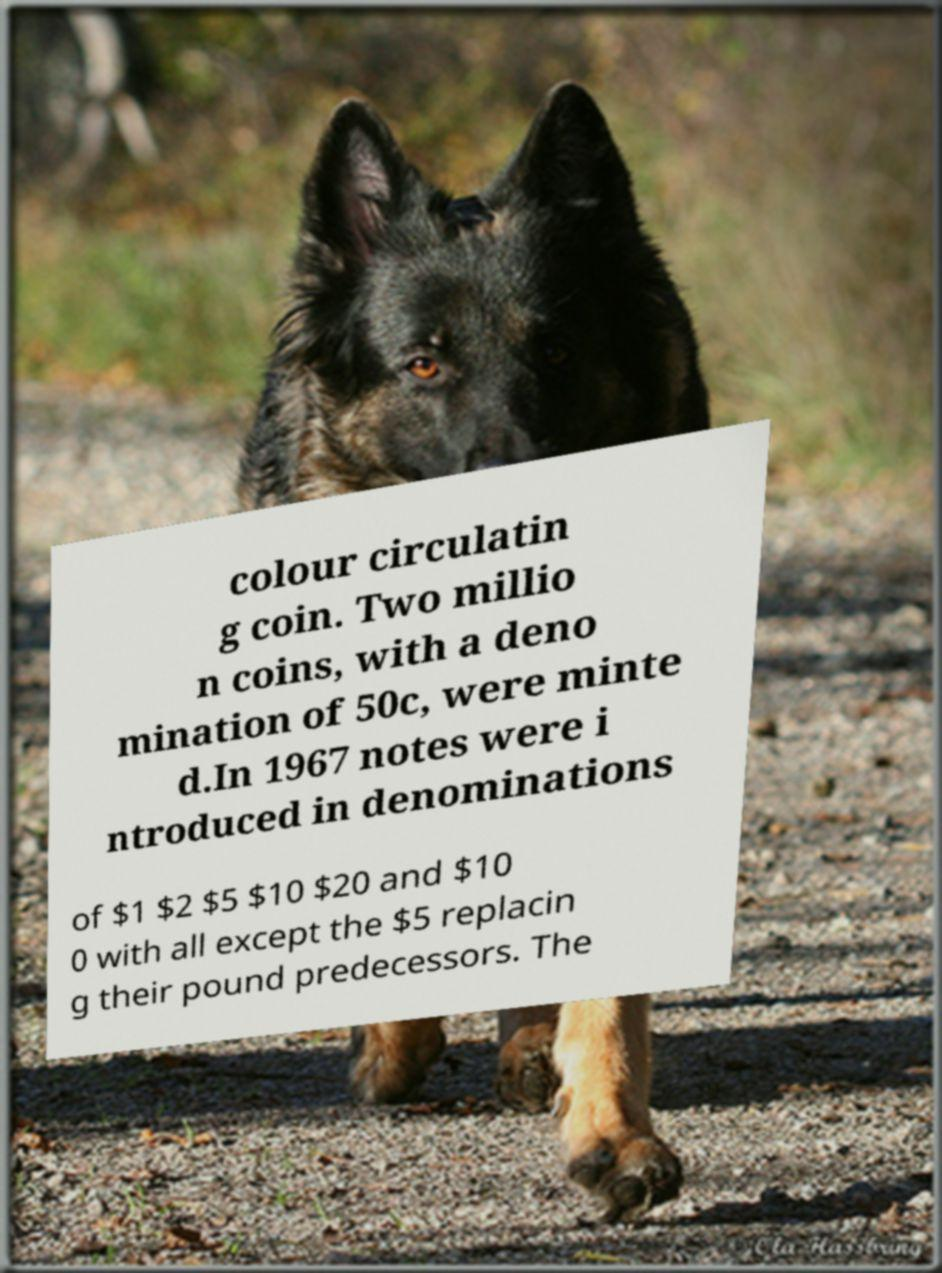Why might the text about the currency be included in an image with this dog? What possible connection could there be? The juxtaposition of the dog with the currency text in the image might symbolically represent the reliability and security often associated with both financial systems and German Shepherds. The loyal nature of the dog could metaphorically underline the trust and solidity promised by the new currency system introduced in 1967. 